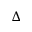Convert formula to latex. <formula><loc_0><loc_0><loc_500><loc_500>\Delta</formula> 